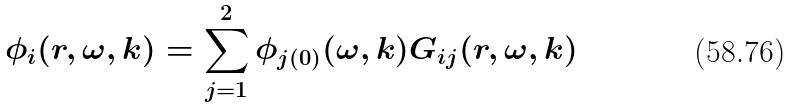<formula> <loc_0><loc_0><loc_500><loc_500>\phi _ { i } ( r , \omega , { k } ) = \sum _ { j = 1 } ^ { 2 } \phi _ { j ( 0 ) } ( \omega , { k } ) G _ { i j } ( r , \omega , { k } )</formula> 